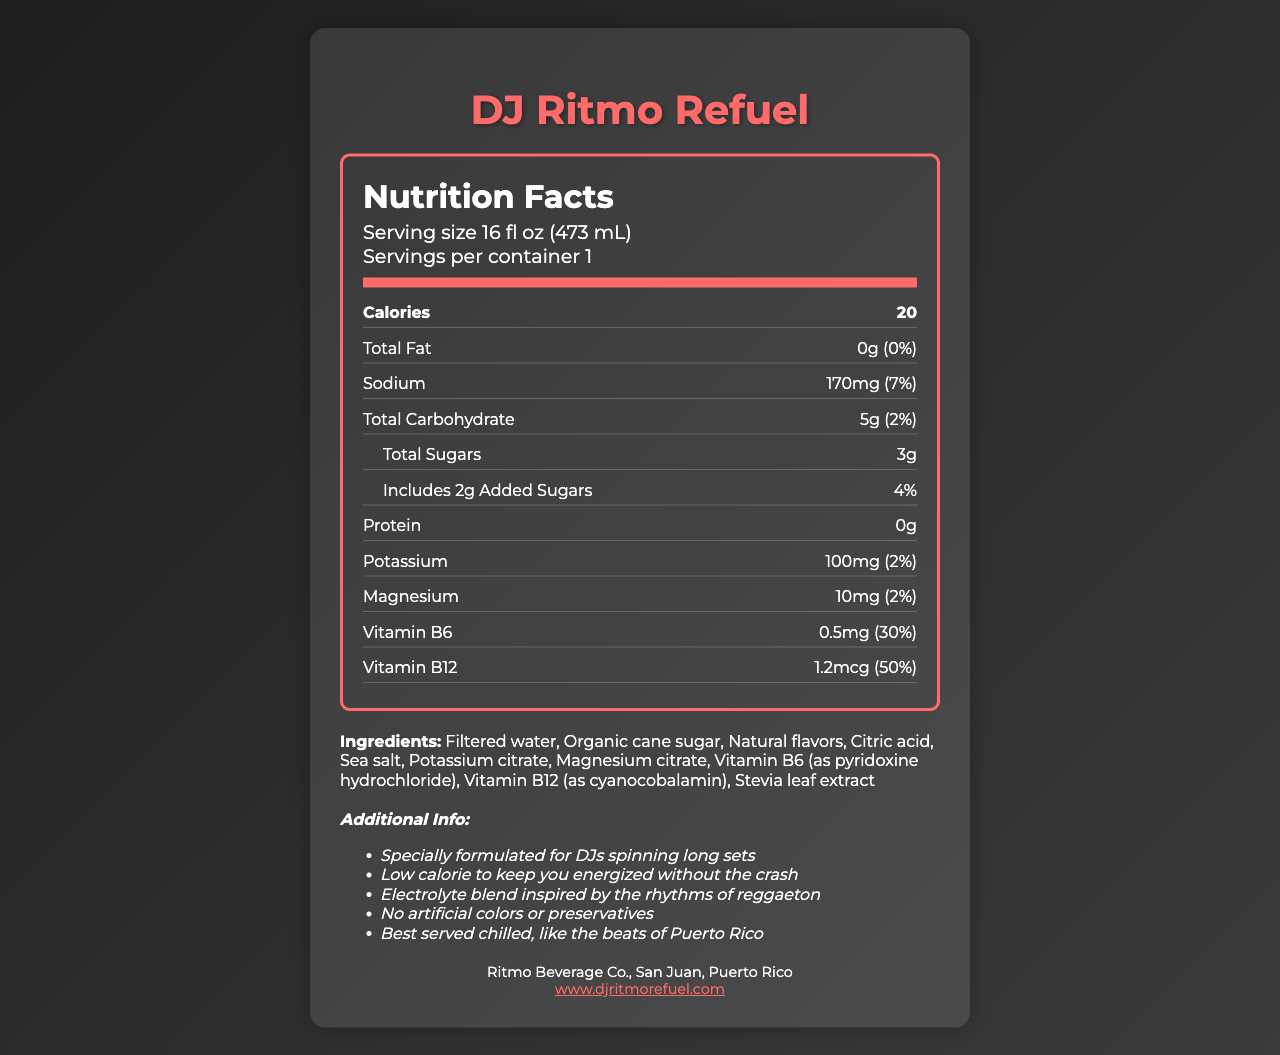what is the product name? The product name is prominently displayed at the top of the document.
Answer: DJ Ritmo Refuel how many calories are in one serving? The calories per serving are listed as 20 in the nutrition facts section.
Answer: 20 what is the amount of Vitamin B12 in one serving? The amount of Vitamin B12 is listed as 1.2mcg in the nutrition facts section.
Answer: 1.2mcg does the beverage contain any protein? The nutrition facts section lists protein as 0g, indicating there is no protein in the beverage.
Answer: No how many grams of added sugars are in the beverage? The document lists added sugars as 2g in the nutrition facts section.
Answer: 2g what are the ingredients in this beverage? The ingredients are listed in a paragraph under the "Ingredients" section.
Answer: Filtered water, Organic cane sugar, Natural flavors, Citric acid, Sea salt, Potassium citrate, Magnesium citrate, Vitamin B6 (as pyridoxine hydrochloride), Vitamin B12 (as cyanocobalamin), Stevia leaf extract. who is the manufacturer of this beverage? The manufacturer information is provided towards the end of the document.
Answer: Ritmo Beverage Co., San Juan, Puerto Rico how much sodium is in one serving? The sodium content per serving is listed as 170mg in the nutrition facts section.
Answer: 170mg what is the daily value percentage for magnesium per serving? The daily value percentage for magnesium per serving is listed as 2% in the nutrition facts section.
Answer: 2% what is the serving size of DJ Ritmo Refuel? The serving size is listed as 16 fl oz (473 mL) in the nutrition facts section.
Answer: 16 fl oz (473 mL) which of these is not an ingredient in DJ Ritmo Refuel? A. Citric acid B. Natural flavors C. Aspartame D. Stevia leaf extract Aspartame is not listed in the ingredients section; the other options are.
Answer: C. Aspartame how many servings are in one container of DJ Ritmo Refuel? A. 1 B. 2 C. 3 D. 4 The servings per container are listed as 1 in the nutrition facts section.
Answer: A. 1 does this beverage contain any artificial colors or preservatives? The additional information states "No artificial colors or preservatives".
Answer: No is this beverage suitable for someone with a soy allergy? The allergen info states it is produced in a facility that processes soy, but does not confirm safety for someone with a soy allergy.
Answer: Not enough information summarize the main idea of the document. The document provides detailed nutritional information, ingredients, allergen info, and additional info tailored for DJs, manufactured by Ritmo Beverage Co.
Answer: DJ Ritmo Refuel is a low-calorie, electrolyte-enhanced beverage designed for long DJ sets, offering hydration with no artificial colors or preservatives. It contains essential vitamins and minerals and is best served chilled. 